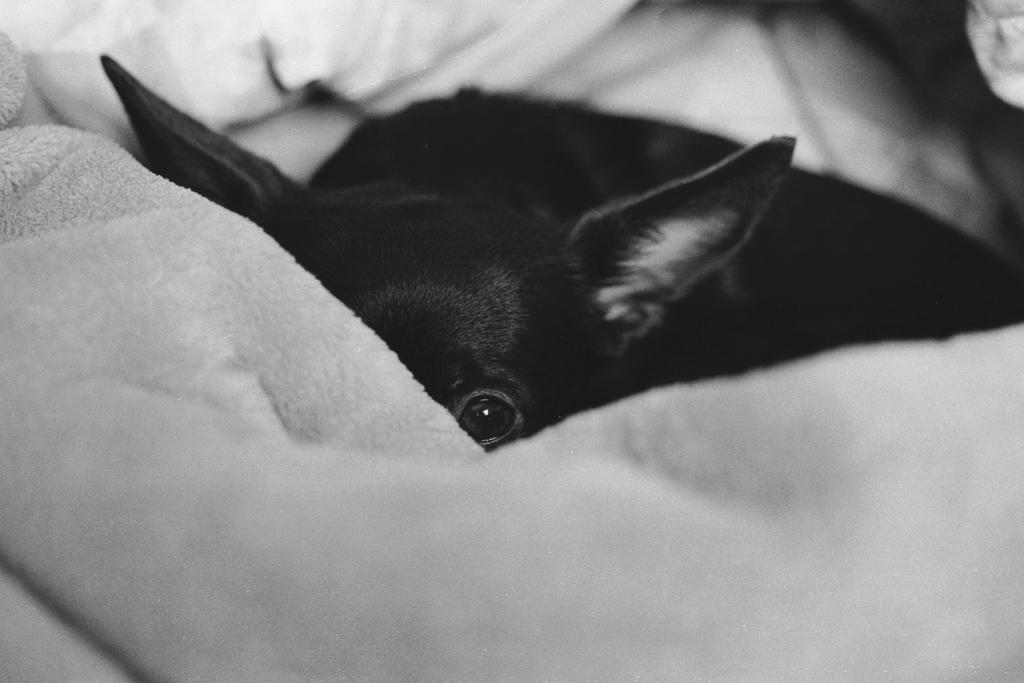What type of creature is present in the image? There is an animal in the image. Can you describe the animal's location or surroundings? The animal is on a blanket. How many visitors are present in the image? There is no mention of visitors in the image; it only features an animal on a blanket. What type of button can be seen on the animal's fur? There is no button present on the animal's fur in the image. 